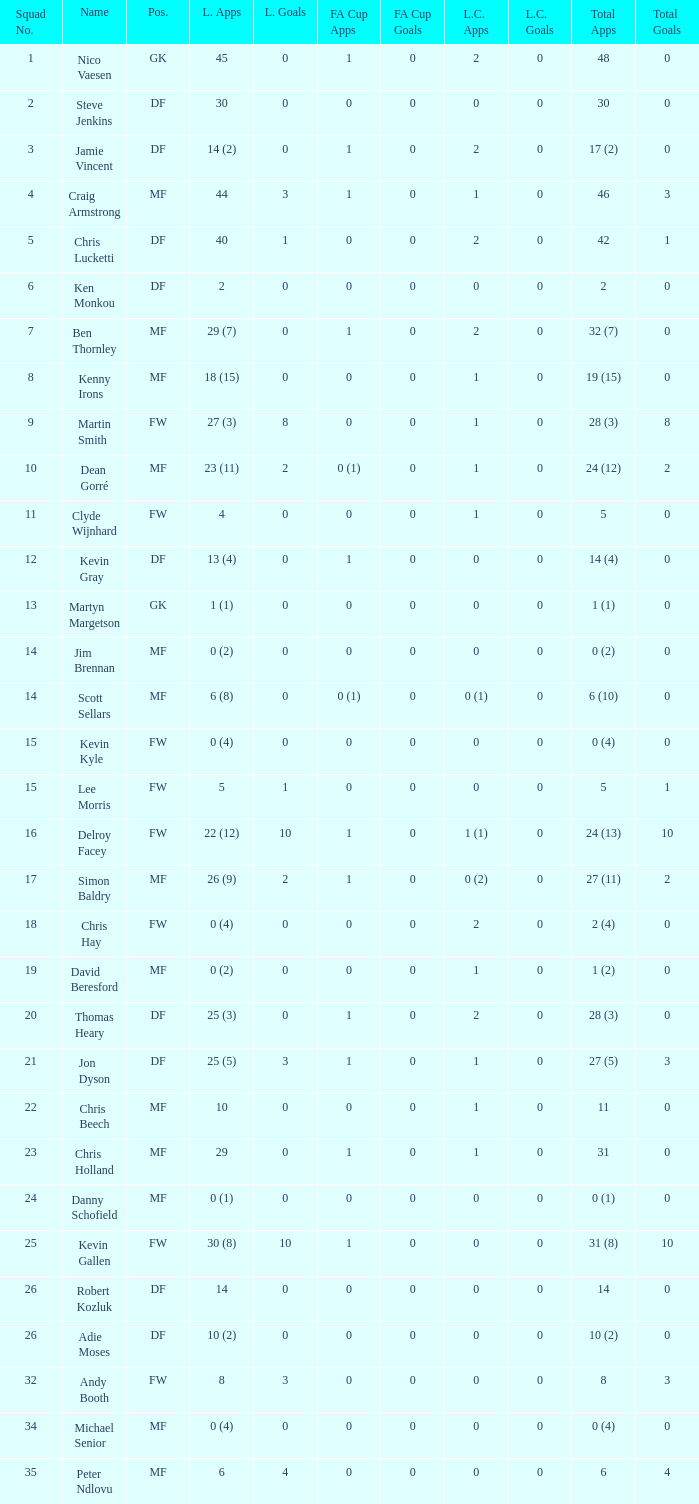Can you tell me the sum of FA Cup Goals that has the League Cup Goals larger than 0? None. 